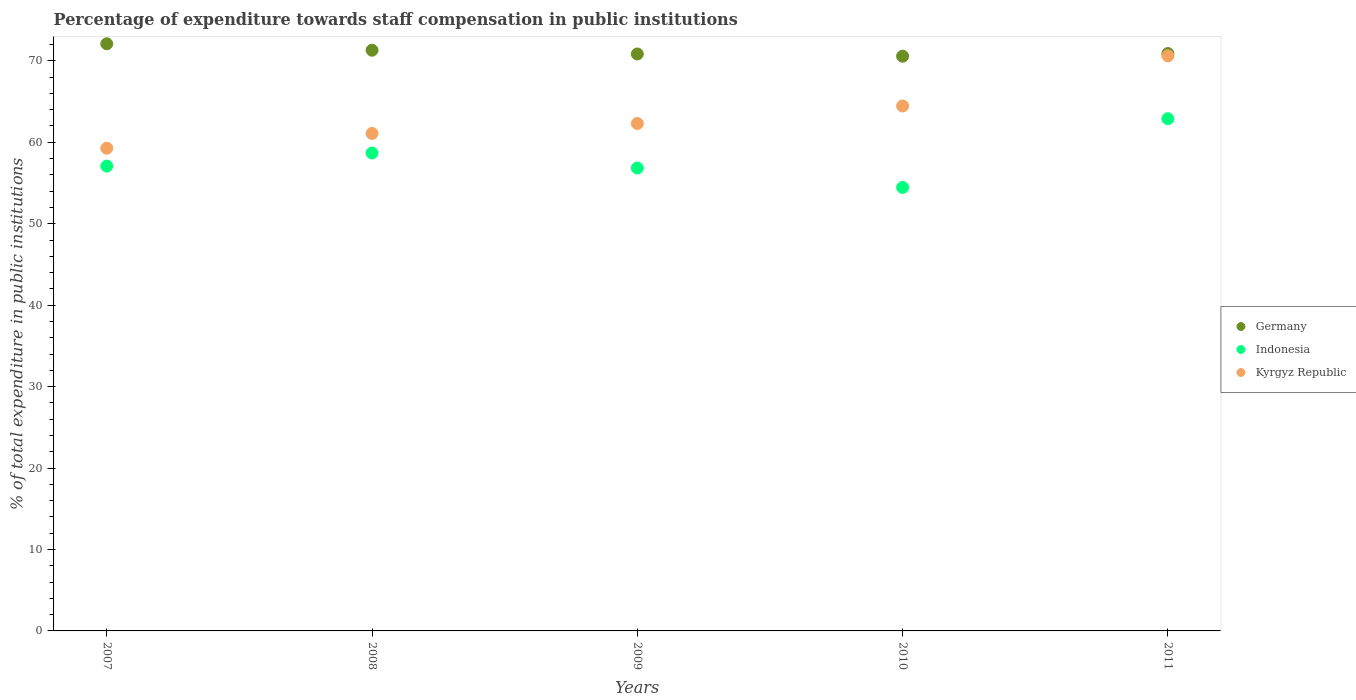What is the percentage of expenditure towards staff compensation in Germany in 2010?
Make the answer very short. 70.57. Across all years, what is the maximum percentage of expenditure towards staff compensation in Germany?
Give a very brief answer. 72.1. Across all years, what is the minimum percentage of expenditure towards staff compensation in Germany?
Provide a succinct answer. 70.57. In which year was the percentage of expenditure towards staff compensation in Kyrgyz Republic maximum?
Your response must be concise. 2011. What is the total percentage of expenditure towards staff compensation in Indonesia in the graph?
Your response must be concise. 289.94. What is the difference between the percentage of expenditure towards staff compensation in Indonesia in 2010 and that in 2011?
Your answer should be compact. -8.44. What is the difference between the percentage of expenditure towards staff compensation in Indonesia in 2008 and the percentage of expenditure towards staff compensation in Germany in 2010?
Provide a succinct answer. -11.89. What is the average percentage of expenditure towards staff compensation in Indonesia per year?
Offer a terse response. 57.99. In the year 2009, what is the difference between the percentage of expenditure towards staff compensation in Kyrgyz Republic and percentage of expenditure towards staff compensation in Indonesia?
Provide a short and direct response. 5.46. What is the ratio of the percentage of expenditure towards staff compensation in Germany in 2007 to that in 2011?
Provide a succinct answer. 1.02. Is the difference between the percentage of expenditure towards staff compensation in Kyrgyz Republic in 2008 and 2009 greater than the difference between the percentage of expenditure towards staff compensation in Indonesia in 2008 and 2009?
Ensure brevity in your answer.  No. What is the difference between the highest and the second highest percentage of expenditure towards staff compensation in Germany?
Offer a terse response. 0.79. What is the difference between the highest and the lowest percentage of expenditure towards staff compensation in Indonesia?
Provide a succinct answer. 8.44. Is the sum of the percentage of expenditure towards staff compensation in Indonesia in 2007 and 2008 greater than the maximum percentage of expenditure towards staff compensation in Kyrgyz Republic across all years?
Your answer should be very brief. Yes. Does the percentage of expenditure towards staff compensation in Indonesia monotonically increase over the years?
Give a very brief answer. No. How many dotlines are there?
Provide a short and direct response. 3. Are the values on the major ticks of Y-axis written in scientific E-notation?
Give a very brief answer. No. Does the graph contain any zero values?
Provide a succinct answer. No. How many legend labels are there?
Offer a very short reply. 3. How are the legend labels stacked?
Offer a terse response. Vertical. What is the title of the graph?
Ensure brevity in your answer.  Percentage of expenditure towards staff compensation in public institutions. Does "Hungary" appear as one of the legend labels in the graph?
Offer a terse response. No. What is the label or title of the X-axis?
Give a very brief answer. Years. What is the label or title of the Y-axis?
Give a very brief answer. % of total expenditure in public institutions. What is the % of total expenditure in public institutions of Germany in 2007?
Make the answer very short. 72.1. What is the % of total expenditure in public institutions in Indonesia in 2007?
Provide a short and direct response. 57.07. What is the % of total expenditure in public institutions of Kyrgyz Republic in 2007?
Provide a succinct answer. 59.27. What is the % of total expenditure in public institutions in Germany in 2008?
Your answer should be compact. 71.3. What is the % of total expenditure in public institutions in Indonesia in 2008?
Provide a succinct answer. 58.68. What is the % of total expenditure in public institutions of Kyrgyz Republic in 2008?
Provide a short and direct response. 61.09. What is the % of total expenditure in public institutions of Germany in 2009?
Your answer should be compact. 70.84. What is the % of total expenditure in public institutions of Indonesia in 2009?
Give a very brief answer. 56.84. What is the % of total expenditure in public institutions in Kyrgyz Republic in 2009?
Offer a very short reply. 62.3. What is the % of total expenditure in public institutions in Germany in 2010?
Your response must be concise. 70.57. What is the % of total expenditure in public institutions of Indonesia in 2010?
Offer a terse response. 54.45. What is the % of total expenditure in public institutions of Kyrgyz Republic in 2010?
Your response must be concise. 64.46. What is the % of total expenditure in public institutions in Germany in 2011?
Keep it short and to the point. 70.89. What is the % of total expenditure in public institutions of Indonesia in 2011?
Make the answer very short. 62.89. What is the % of total expenditure in public institutions in Kyrgyz Republic in 2011?
Provide a succinct answer. 70.61. Across all years, what is the maximum % of total expenditure in public institutions of Germany?
Keep it short and to the point. 72.1. Across all years, what is the maximum % of total expenditure in public institutions in Indonesia?
Your answer should be very brief. 62.89. Across all years, what is the maximum % of total expenditure in public institutions of Kyrgyz Republic?
Your answer should be compact. 70.61. Across all years, what is the minimum % of total expenditure in public institutions of Germany?
Your answer should be very brief. 70.57. Across all years, what is the minimum % of total expenditure in public institutions of Indonesia?
Provide a succinct answer. 54.45. Across all years, what is the minimum % of total expenditure in public institutions of Kyrgyz Republic?
Provide a short and direct response. 59.27. What is the total % of total expenditure in public institutions of Germany in the graph?
Your response must be concise. 355.71. What is the total % of total expenditure in public institutions of Indonesia in the graph?
Your answer should be compact. 289.94. What is the total % of total expenditure in public institutions in Kyrgyz Republic in the graph?
Your answer should be very brief. 317.73. What is the difference between the % of total expenditure in public institutions of Germany in 2007 and that in 2008?
Your answer should be very brief. 0.79. What is the difference between the % of total expenditure in public institutions of Indonesia in 2007 and that in 2008?
Ensure brevity in your answer.  -1.61. What is the difference between the % of total expenditure in public institutions in Kyrgyz Republic in 2007 and that in 2008?
Provide a short and direct response. -1.82. What is the difference between the % of total expenditure in public institutions in Germany in 2007 and that in 2009?
Your response must be concise. 1.25. What is the difference between the % of total expenditure in public institutions of Indonesia in 2007 and that in 2009?
Keep it short and to the point. 0.23. What is the difference between the % of total expenditure in public institutions of Kyrgyz Republic in 2007 and that in 2009?
Ensure brevity in your answer.  -3.04. What is the difference between the % of total expenditure in public institutions of Germany in 2007 and that in 2010?
Your response must be concise. 1.53. What is the difference between the % of total expenditure in public institutions of Indonesia in 2007 and that in 2010?
Keep it short and to the point. 2.62. What is the difference between the % of total expenditure in public institutions in Kyrgyz Republic in 2007 and that in 2010?
Your response must be concise. -5.19. What is the difference between the % of total expenditure in public institutions of Germany in 2007 and that in 2011?
Provide a short and direct response. 1.2. What is the difference between the % of total expenditure in public institutions of Indonesia in 2007 and that in 2011?
Give a very brief answer. -5.82. What is the difference between the % of total expenditure in public institutions of Kyrgyz Republic in 2007 and that in 2011?
Make the answer very short. -11.34. What is the difference between the % of total expenditure in public institutions in Germany in 2008 and that in 2009?
Make the answer very short. 0.46. What is the difference between the % of total expenditure in public institutions of Indonesia in 2008 and that in 2009?
Ensure brevity in your answer.  1.84. What is the difference between the % of total expenditure in public institutions of Kyrgyz Republic in 2008 and that in 2009?
Provide a short and direct response. -1.22. What is the difference between the % of total expenditure in public institutions in Germany in 2008 and that in 2010?
Provide a succinct answer. 0.73. What is the difference between the % of total expenditure in public institutions in Indonesia in 2008 and that in 2010?
Ensure brevity in your answer.  4.23. What is the difference between the % of total expenditure in public institutions of Kyrgyz Republic in 2008 and that in 2010?
Offer a terse response. -3.37. What is the difference between the % of total expenditure in public institutions in Germany in 2008 and that in 2011?
Provide a succinct answer. 0.41. What is the difference between the % of total expenditure in public institutions of Indonesia in 2008 and that in 2011?
Your answer should be very brief. -4.21. What is the difference between the % of total expenditure in public institutions in Kyrgyz Republic in 2008 and that in 2011?
Your answer should be very brief. -9.53. What is the difference between the % of total expenditure in public institutions of Germany in 2009 and that in 2010?
Make the answer very short. 0.27. What is the difference between the % of total expenditure in public institutions in Indonesia in 2009 and that in 2010?
Your response must be concise. 2.39. What is the difference between the % of total expenditure in public institutions in Kyrgyz Republic in 2009 and that in 2010?
Your response must be concise. -2.15. What is the difference between the % of total expenditure in public institutions in Germany in 2009 and that in 2011?
Your answer should be very brief. -0.05. What is the difference between the % of total expenditure in public institutions in Indonesia in 2009 and that in 2011?
Give a very brief answer. -6.05. What is the difference between the % of total expenditure in public institutions in Kyrgyz Republic in 2009 and that in 2011?
Provide a succinct answer. -8.31. What is the difference between the % of total expenditure in public institutions in Germany in 2010 and that in 2011?
Offer a very short reply. -0.32. What is the difference between the % of total expenditure in public institutions of Indonesia in 2010 and that in 2011?
Offer a very short reply. -8.44. What is the difference between the % of total expenditure in public institutions of Kyrgyz Republic in 2010 and that in 2011?
Ensure brevity in your answer.  -6.16. What is the difference between the % of total expenditure in public institutions in Germany in 2007 and the % of total expenditure in public institutions in Indonesia in 2008?
Offer a terse response. 13.41. What is the difference between the % of total expenditure in public institutions in Germany in 2007 and the % of total expenditure in public institutions in Kyrgyz Republic in 2008?
Your response must be concise. 11.01. What is the difference between the % of total expenditure in public institutions in Indonesia in 2007 and the % of total expenditure in public institutions in Kyrgyz Republic in 2008?
Ensure brevity in your answer.  -4.01. What is the difference between the % of total expenditure in public institutions in Germany in 2007 and the % of total expenditure in public institutions in Indonesia in 2009?
Keep it short and to the point. 15.26. What is the difference between the % of total expenditure in public institutions of Germany in 2007 and the % of total expenditure in public institutions of Kyrgyz Republic in 2009?
Keep it short and to the point. 9.79. What is the difference between the % of total expenditure in public institutions in Indonesia in 2007 and the % of total expenditure in public institutions in Kyrgyz Republic in 2009?
Your response must be concise. -5.23. What is the difference between the % of total expenditure in public institutions of Germany in 2007 and the % of total expenditure in public institutions of Indonesia in 2010?
Provide a short and direct response. 17.64. What is the difference between the % of total expenditure in public institutions of Germany in 2007 and the % of total expenditure in public institutions of Kyrgyz Republic in 2010?
Offer a very short reply. 7.64. What is the difference between the % of total expenditure in public institutions in Indonesia in 2007 and the % of total expenditure in public institutions in Kyrgyz Republic in 2010?
Your answer should be very brief. -7.38. What is the difference between the % of total expenditure in public institutions in Germany in 2007 and the % of total expenditure in public institutions in Indonesia in 2011?
Your answer should be compact. 9.2. What is the difference between the % of total expenditure in public institutions in Germany in 2007 and the % of total expenditure in public institutions in Kyrgyz Republic in 2011?
Your answer should be very brief. 1.48. What is the difference between the % of total expenditure in public institutions in Indonesia in 2007 and the % of total expenditure in public institutions in Kyrgyz Republic in 2011?
Your response must be concise. -13.54. What is the difference between the % of total expenditure in public institutions of Germany in 2008 and the % of total expenditure in public institutions of Indonesia in 2009?
Provide a short and direct response. 14.46. What is the difference between the % of total expenditure in public institutions of Germany in 2008 and the % of total expenditure in public institutions of Kyrgyz Republic in 2009?
Your answer should be compact. 9. What is the difference between the % of total expenditure in public institutions of Indonesia in 2008 and the % of total expenditure in public institutions of Kyrgyz Republic in 2009?
Your answer should be very brief. -3.62. What is the difference between the % of total expenditure in public institutions in Germany in 2008 and the % of total expenditure in public institutions in Indonesia in 2010?
Offer a terse response. 16.85. What is the difference between the % of total expenditure in public institutions of Germany in 2008 and the % of total expenditure in public institutions of Kyrgyz Republic in 2010?
Your response must be concise. 6.85. What is the difference between the % of total expenditure in public institutions in Indonesia in 2008 and the % of total expenditure in public institutions in Kyrgyz Republic in 2010?
Give a very brief answer. -5.77. What is the difference between the % of total expenditure in public institutions of Germany in 2008 and the % of total expenditure in public institutions of Indonesia in 2011?
Provide a succinct answer. 8.41. What is the difference between the % of total expenditure in public institutions of Germany in 2008 and the % of total expenditure in public institutions of Kyrgyz Republic in 2011?
Offer a very short reply. 0.69. What is the difference between the % of total expenditure in public institutions in Indonesia in 2008 and the % of total expenditure in public institutions in Kyrgyz Republic in 2011?
Offer a very short reply. -11.93. What is the difference between the % of total expenditure in public institutions in Germany in 2009 and the % of total expenditure in public institutions in Indonesia in 2010?
Your answer should be very brief. 16.39. What is the difference between the % of total expenditure in public institutions of Germany in 2009 and the % of total expenditure in public institutions of Kyrgyz Republic in 2010?
Give a very brief answer. 6.39. What is the difference between the % of total expenditure in public institutions of Indonesia in 2009 and the % of total expenditure in public institutions of Kyrgyz Republic in 2010?
Your answer should be very brief. -7.62. What is the difference between the % of total expenditure in public institutions in Germany in 2009 and the % of total expenditure in public institutions in Indonesia in 2011?
Your answer should be very brief. 7.95. What is the difference between the % of total expenditure in public institutions in Germany in 2009 and the % of total expenditure in public institutions in Kyrgyz Republic in 2011?
Ensure brevity in your answer.  0.23. What is the difference between the % of total expenditure in public institutions of Indonesia in 2009 and the % of total expenditure in public institutions of Kyrgyz Republic in 2011?
Ensure brevity in your answer.  -13.77. What is the difference between the % of total expenditure in public institutions of Germany in 2010 and the % of total expenditure in public institutions of Indonesia in 2011?
Make the answer very short. 7.68. What is the difference between the % of total expenditure in public institutions of Germany in 2010 and the % of total expenditure in public institutions of Kyrgyz Republic in 2011?
Provide a succinct answer. -0.04. What is the difference between the % of total expenditure in public institutions in Indonesia in 2010 and the % of total expenditure in public institutions in Kyrgyz Republic in 2011?
Offer a terse response. -16.16. What is the average % of total expenditure in public institutions of Germany per year?
Keep it short and to the point. 71.14. What is the average % of total expenditure in public institutions of Indonesia per year?
Ensure brevity in your answer.  57.99. What is the average % of total expenditure in public institutions in Kyrgyz Republic per year?
Provide a short and direct response. 63.55. In the year 2007, what is the difference between the % of total expenditure in public institutions of Germany and % of total expenditure in public institutions of Indonesia?
Offer a very short reply. 15.02. In the year 2007, what is the difference between the % of total expenditure in public institutions in Germany and % of total expenditure in public institutions in Kyrgyz Republic?
Offer a terse response. 12.83. In the year 2007, what is the difference between the % of total expenditure in public institutions of Indonesia and % of total expenditure in public institutions of Kyrgyz Republic?
Offer a terse response. -2.2. In the year 2008, what is the difference between the % of total expenditure in public institutions of Germany and % of total expenditure in public institutions of Indonesia?
Ensure brevity in your answer.  12.62. In the year 2008, what is the difference between the % of total expenditure in public institutions in Germany and % of total expenditure in public institutions in Kyrgyz Republic?
Ensure brevity in your answer.  10.22. In the year 2008, what is the difference between the % of total expenditure in public institutions of Indonesia and % of total expenditure in public institutions of Kyrgyz Republic?
Offer a terse response. -2.41. In the year 2009, what is the difference between the % of total expenditure in public institutions in Germany and % of total expenditure in public institutions in Indonesia?
Provide a short and direct response. 14. In the year 2009, what is the difference between the % of total expenditure in public institutions of Germany and % of total expenditure in public institutions of Kyrgyz Republic?
Provide a succinct answer. 8.54. In the year 2009, what is the difference between the % of total expenditure in public institutions of Indonesia and % of total expenditure in public institutions of Kyrgyz Republic?
Provide a short and direct response. -5.46. In the year 2010, what is the difference between the % of total expenditure in public institutions in Germany and % of total expenditure in public institutions in Indonesia?
Your response must be concise. 16.12. In the year 2010, what is the difference between the % of total expenditure in public institutions of Germany and % of total expenditure in public institutions of Kyrgyz Republic?
Give a very brief answer. 6.11. In the year 2010, what is the difference between the % of total expenditure in public institutions of Indonesia and % of total expenditure in public institutions of Kyrgyz Republic?
Keep it short and to the point. -10. In the year 2011, what is the difference between the % of total expenditure in public institutions in Germany and % of total expenditure in public institutions in Indonesia?
Your answer should be compact. 8. In the year 2011, what is the difference between the % of total expenditure in public institutions in Germany and % of total expenditure in public institutions in Kyrgyz Republic?
Ensure brevity in your answer.  0.28. In the year 2011, what is the difference between the % of total expenditure in public institutions in Indonesia and % of total expenditure in public institutions in Kyrgyz Republic?
Ensure brevity in your answer.  -7.72. What is the ratio of the % of total expenditure in public institutions of Germany in 2007 to that in 2008?
Your answer should be compact. 1.01. What is the ratio of the % of total expenditure in public institutions of Indonesia in 2007 to that in 2008?
Ensure brevity in your answer.  0.97. What is the ratio of the % of total expenditure in public institutions of Kyrgyz Republic in 2007 to that in 2008?
Your answer should be compact. 0.97. What is the ratio of the % of total expenditure in public institutions in Germany in 2007 to that in 2009?
Make the answer very short. 1.02. What is the ratio of the % of total expenditure in public institutions of Indonesia in 2007 to that in 2009?
Make the answer very short. 1. What is the ratio of the % of total expenditure in public institutions of Kyrgyz Republic in 2007 to that in 2009?
Keep it short and to the point. 0.95. What is the ratio of the % of total expenditure in public institutions of Germany in 2007 to that in 2010?
Your answer should be compact. 1.02. What is the ratio of the % of total expenditure in public institutions in Indonesia in 2007 to that in 2010?
Your response must be concise. 1.05. What is the ratio of the % of total expenditure in public institutions in Kyrgyz Republic in 2007 to that in 2010?
Give a very brief answer. 0.92. What is the ratio of the % of total expenditure in public institutions in Indonesia in 2007 to that in 2011?
Offer a very short reply. 0.91. What is the ratio of the % of total expenditure in public institutions in Kyrgyz Republic in 2007 to that in 2011?
Your answer should be very brief. 0.84. What is the ratio of the % of total expenditure in public institutions of Germany in 2008 to that in 2009?
Your answer should be compact. 1.01. What is the ratio of the % of total expenditure in public institutions of Indonesia in 2008 to that in 2009?
Make the answer very short. 1.03. What is the ratio of the % of total expenditure in public institutions in Kyrgyz Republic in 2008 to that in 2009?
Keep it short and to the point. 0.98. What is the ratio of the % of total expenditure in public institutions in Germany in 2008 to that in 2010?
Provide a short and direct response. 1.01. What is the ratio of the % of total expenditure in public institutions of Indonesia in 2008 to that in 2010?
Offer a terse response. 1.08. What is the ratio of the % of total expenditure in public institutions of Kyrgyz Republic in 2008 to that in 2010?
Make the answer very short. 0.95. What is the ratio of the % of total expenditure in public institutions of Indonesia in 2008 to that in 2011?
Offer a terse response. 0.93. What is the ratio of the % of total expenditure in public institutions in Kyrgyz Republic in 2008 to that in 2011?
Offer a terse response. 0.87. What is the ratio of the % of total expenditure in public institutions of Indonesia in 2009 to that in 2010?
Offer a very short reply. 1.04. What is the ratio of the % of total expenditure in public institutions in Kyrgyz Republic in 2009 to that in 2010?
Your answer should be very brief. 0.97. What is the ratio of the % of total expenditure in public institutions in Germany in 2009 to that in 2011?
Ensure brevity in your answer.  1. What is the ratio of the % of total expenditure in public institutions in Indonesia in 2009 to that in 2011?
Keep it short and to the point. 0.9. What is the ratio of the % of total expenditure in public institutions of Kyrgyz Republic in 2009 to that in 2011?
Your answer should be very brief. 0.88. What is the ratio of the % of total expenditure in public institutions in Germany in 2010 to that in 2011?
Ensure brevity in your answer.  1. What is the ratio of the % of total expenditure in public institutions of Indonesia in 2010 to that in 2011?
Give a very brief answer. 0.87. What is the ratio of the % of total expenditure in public institutions in Kyrgyz Republic in 2010 to that in 2011?
Make the answer very short. 0.91. What is the difference between the highest and the second highest % of total expenditure in public institutions of Germany?
Your answer should be very brief. 0.79. What is the difference between the highest and the second highest % of total expenditure in public institutions in Indonesia?
Your answer should be very brief. 4.21. What is the difference between the highest and the second highest % of total expenditure in public institutions of Kyrgyz Republic?
Ensure brevity in your answer.  6.16. What is the difference between the highest and the lowest % of total expenditure in public institutions of Germany?
Provide a succinct answer. 1.53. What is the difference between the highest and the lowest % of total expenditure in public institutions in Indonesia?
Your answer should be very brief. 8.44. What is the difference between the highest and the lowest % of total expenditure in public institutions of Kyrgyz Republic?
Your answer should be very brief. 11.34. 